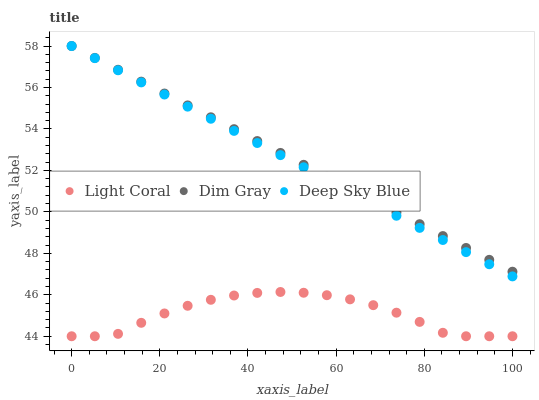Does Light Coral have the minimum area under the curve?
Answer yes or no. Yes. Does Dim Gray have the maximum area under the curve?
Answer yes or no. Yes. Does Deep Sky Blue have the minimum area under the curve?
Answer yes or no. No. Does Deep Sky Blue have the maximum area under the curve?
Answer yes or no. No. Is Dim Gray the smoothest?
Answer yes or no. Yes. Is Light Coral the roughest?
Answer yes or no. Yes. Is Deep Sky Blue the smoothest?
Answer yes or no. No. Is Deep Sky Blue the roughest?
Answer yes or no. No. Does Light Coral have the lowest value?
Answer yes or no. Yes. Does Deep Sky Blue have the lowest value?
Answer yes or no. No. Does Deep Sky Blue have the highest value?
Answer yes or no. Yes. Is Light Coral less than Deep Sky Blue?
Answer yes or no. Yes. Is Deep Sky Blue greater than Light Coral?
Answer yes or no. Yes. Does Deep Sky Blue intersect Dim Gray?
Answer yes or no. Yes. Is Deep Sky Blue less than Dim Gray?
Answer yes or no. No. Is Deep Sky Blue greater than Dim Gray?
Answer yes or no. No. Does Light Coral intersect Deep Sky Blue?
Answer yes or no. No. 